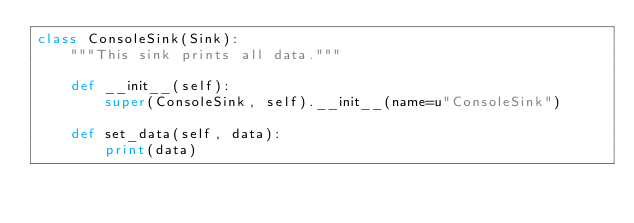Convert code to text. <code><loc_0><loc_0><loc_500><loc_500><_Python_>class ConsoleSink(Sink):
    """This sink prints all data."""

    def __init__(self):
        super(ConsoleSink, self).__init__(name=u"ConsoleSink")

    def set_data(self, data):
        print(data)
</code> 